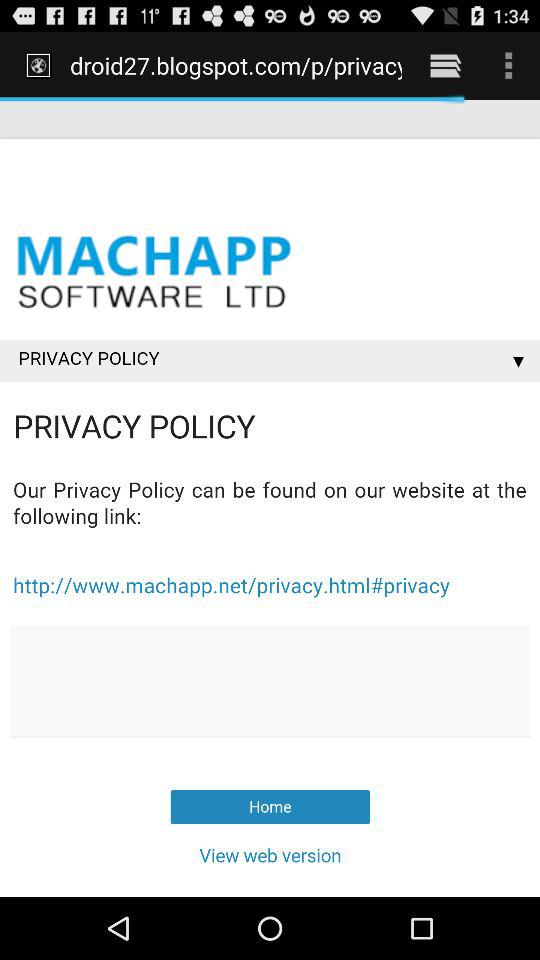What is the URL address of the given application? The URL address is "http://www.machapp.net/privacy.html#privacy". 